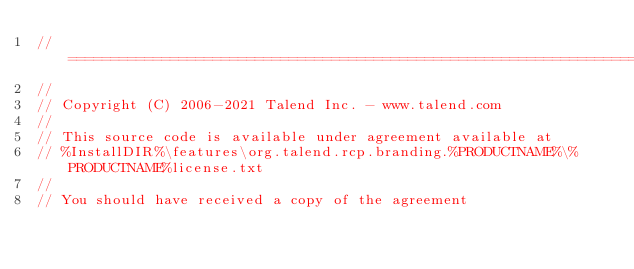Convert code to text. <code><loc_0><loc_0><loc_500><loc_500><_Java_>// ============================================================================
//
// Copyright (C) 2006-2021 Talend Inc. - www.talend.com
//
// This source code is available under agreement available at
// %InstallDIR%\features\org.talend.rcp.branding.%PRODUCTNAME%\%PRODUCTNAME%license.txt
//
// You should have received a copy of the agreement</code> 